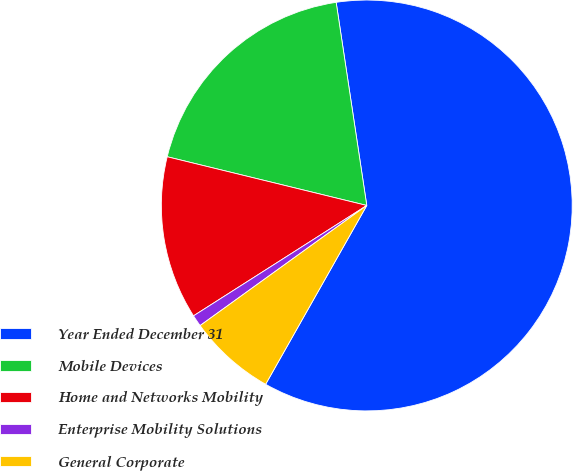Convert chart. <chart><loc_0><loc_0><loc_500><loc_500><pie_chart><fcel>Year Ended December 31<fcel>Mobile Devices<fcel>Home and Networks Mobility<fcel>Enterprise Mobility Solutions<fcel>General Corporate<nl><fcel>60.58%<fcel>18.81%<fcel>12.84%<fcel>0.91%<fcel>6.87%<nl></chart> 